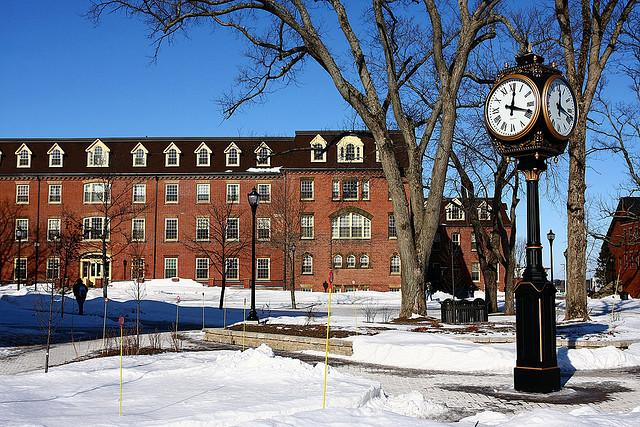What is the coldest place in the area? Please explain your reasoning. shaded area. The coldest place is the shaded area without sunlight. 